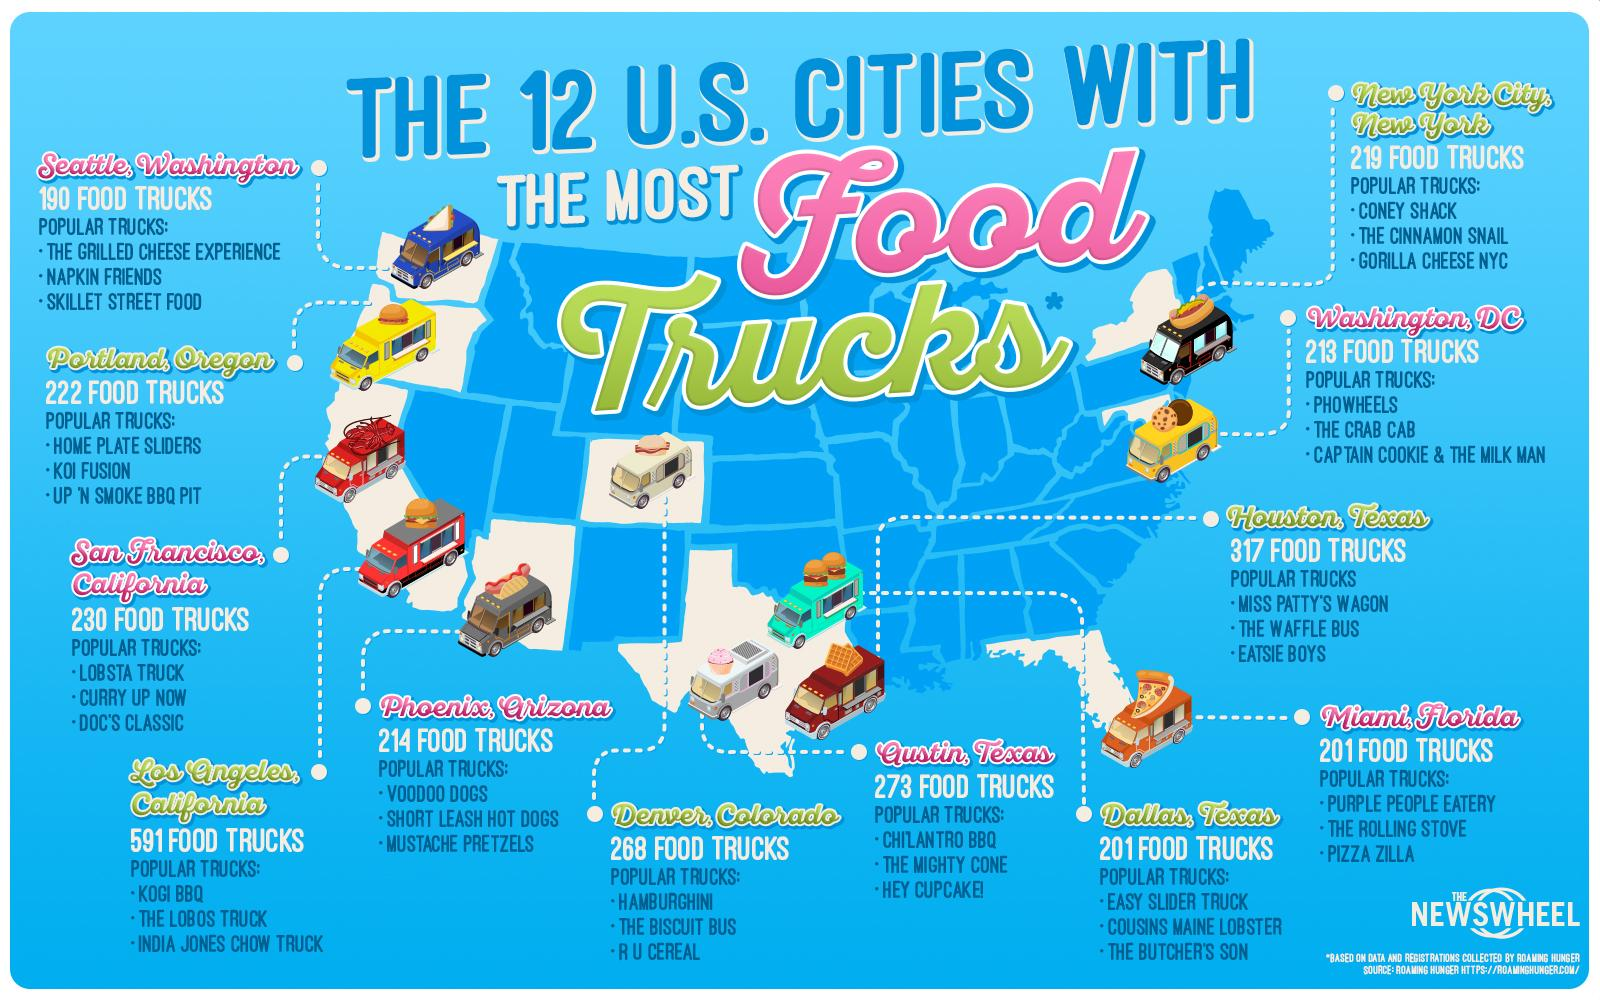Mention a couple of crucial points in this snapshot. In the three cities of Texas, a total of 791 food trucks are present. Forty-one states in the United States have fewer food trucks compared to other states. Nine states have the highest number of food trucks in the United States. San Francisco and Los Angeles are the two cities in California that have the most food trucks. It is Houston, Texas that has the greatest number of food trucks in the United States. 